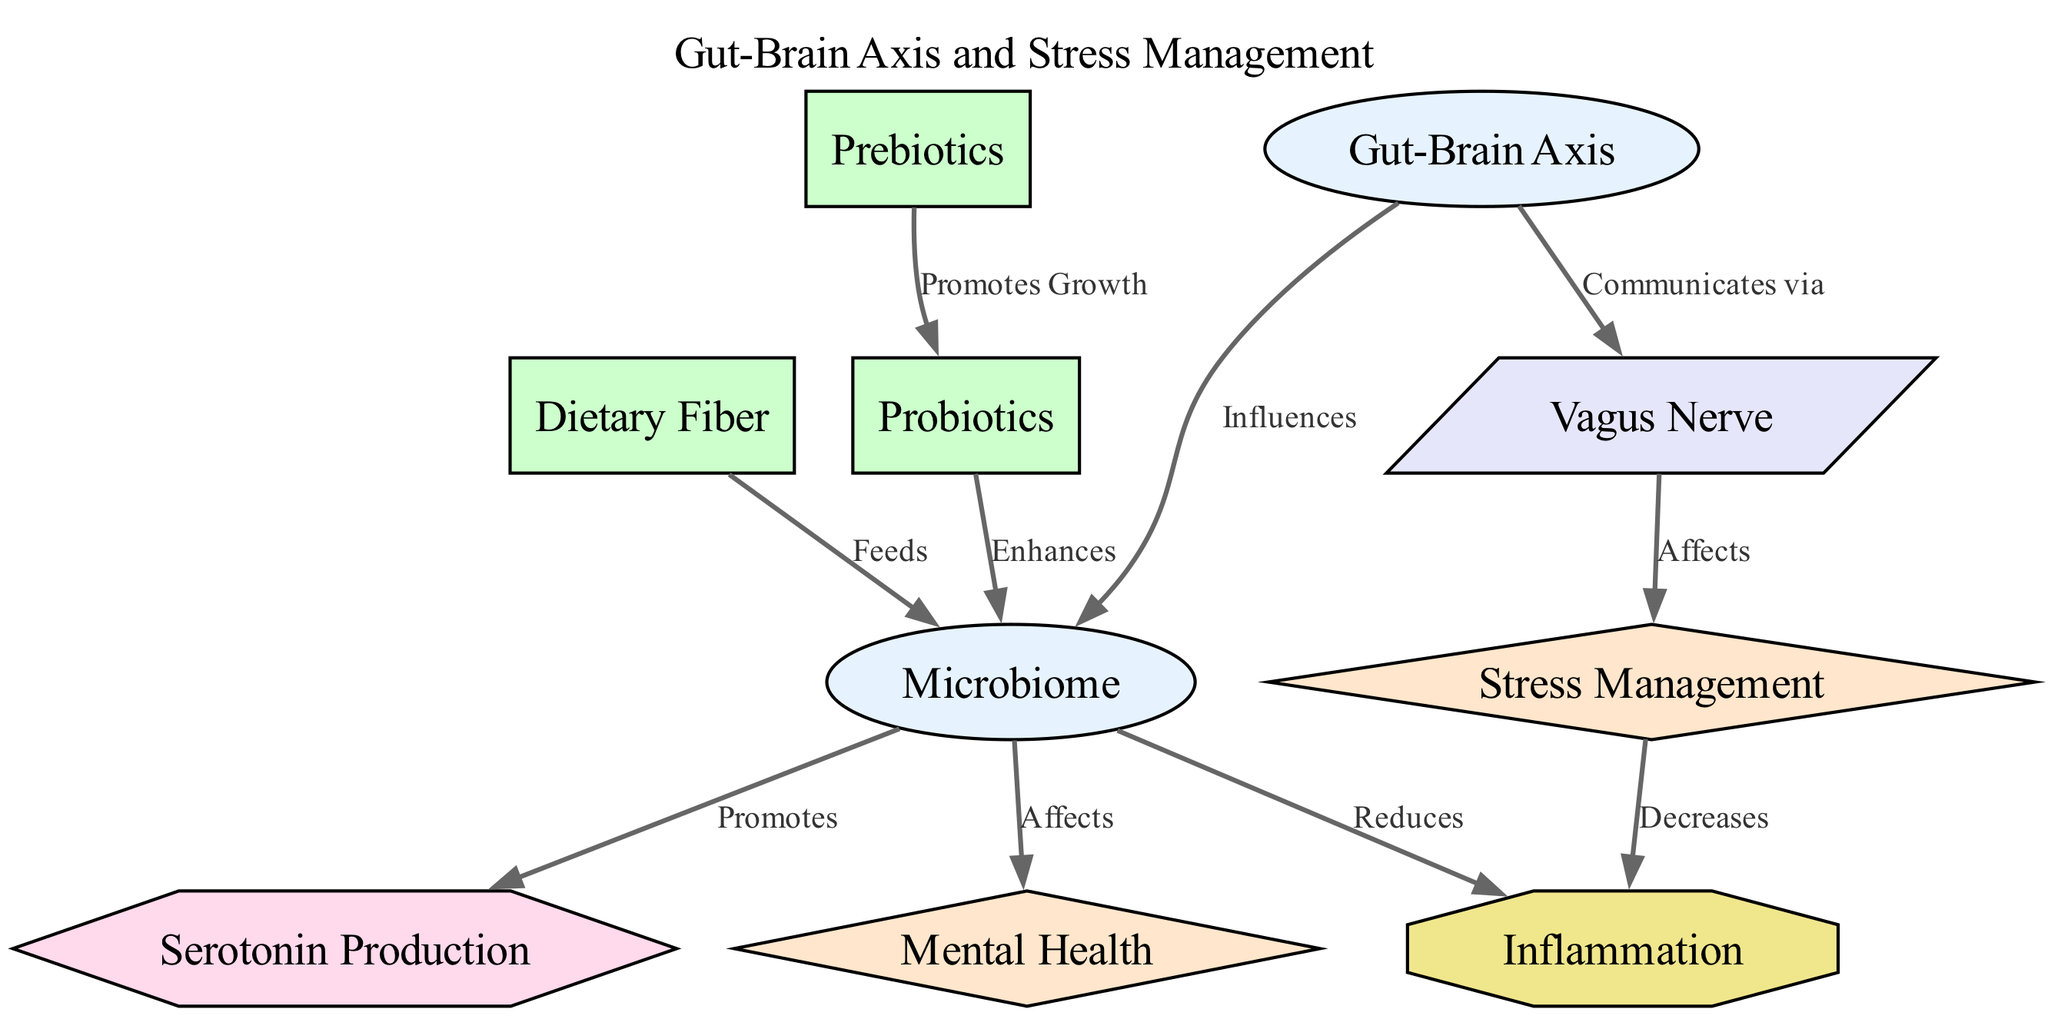What is the main concept illustrated in the diagram? The main concept is the "Gut-Brain Axis," which is the central node and is likely connected to various other nodes illustrating relationships and influences within the system.
Answer: Gut-Brain Axis How many nodes are in the diagram? By counting the entries in the "nodes" section of the data provided, there are a total of 10 unique nodes.
Answer: 10 What nutrient type is indicated as promoting growth of another nutrient? The diagram shows a connection where "Prebiotics" promotes the growth of "Probiotics," indicating a supportive relationship between these two nutrients.
Answer: Promotes Growth Which outcome is influenced by the "Vagus Nerve"? In the diagram, the "Vagus Nerve" is shown to affect "Stress Management," indicating that it plays a significant role in this particular outcome.
Answer: Stress Management What process is promoted by the microbiome according to the diagram? The diagram indicates that the microbiome promotes "Serotonin Production," demonstrating its role in mental health processes.
Answer: Serotonin Production Which factor is shown to decrease due to stress management efforts? The diagram clearly shows that "Stress Management" has a connection to decreasing "Inflammation," highlighting its beneficial effect on this factor.
Answer: Decreases Describe the relationship between dietary fiber and microbiome. The relationship indicates that "Dietary Fiber" feeds the "Microbiome," suggesting that dietary fiber is important for maintaining a healthy microbiome ecosystem.
Answer: Feeds What is the connection between the microbiome and mental health? The diagram illustrates that the microbiome affects "Mental Health," indicating a direct link where gut health impacts overall mental well-being.
Answer: Affects What role does the "Gut-Brain Axis" serve in terms of communication? According to the diagram, the "Gut-Brain Axis" communicates via the "Vagus Nerve," indicating its role as a pathway for signals between the gut and the brain.
Answer: Communicates via 